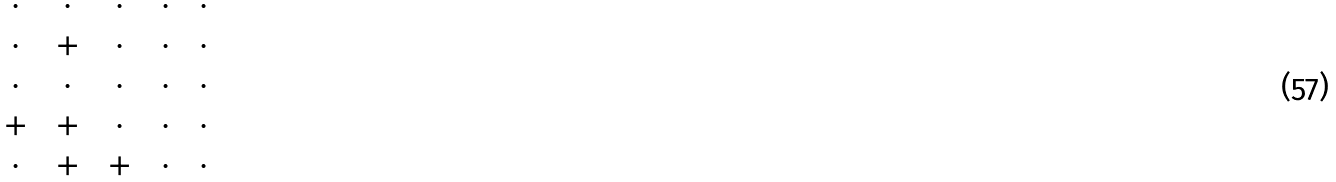Convert formula to latex. <formula><loc_0><loc_0><loc_500><loc_500>\begin{matrix} \, \cdot \, & \, \cdot \, & \, \cdot \, & \, \cdot \, & \, \cdot \, \\ \, \cdot \, & \, + \, & \, \cdot \, & \, \cdot \, & \, \cdot \, \\ \, \cdot \, & \, \cdot \, & \, \cdot \, & \, \cdot \, & \, \cdot \, \\ \, + \, & \, + \, & \, \cdot \, & \, \cdot \, & \, \cdot \, \\ \, \cdot \, & \, + \, & \, + \, & \, \cdot \, & \, \cdot \, \\ \end{matrix}</formula> 